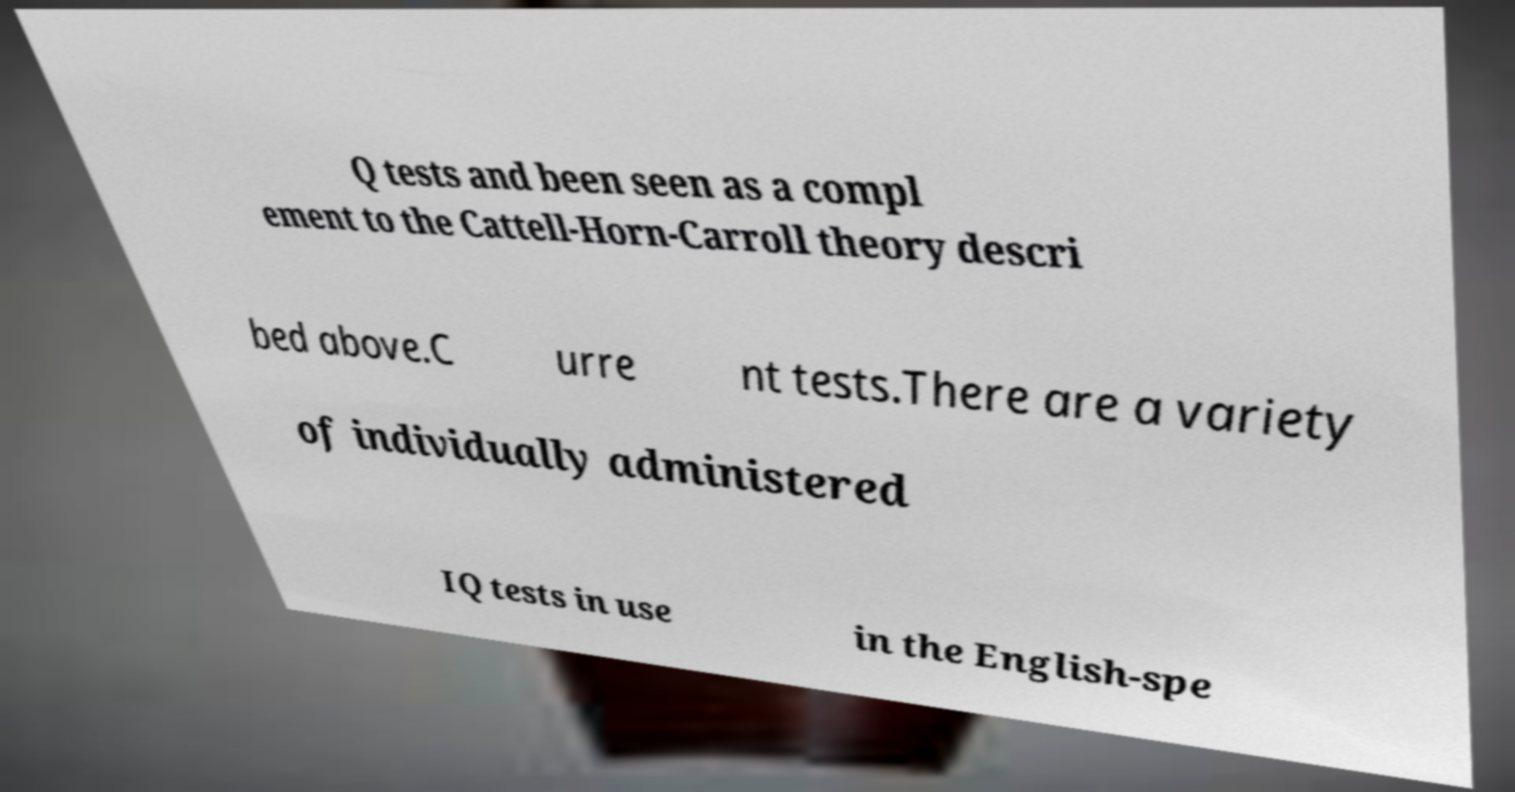I need the written content from this picture converted into text. Can you do that? Q tests and been seen as a compl ement to the Cattell-Horn-Carroll theory descri bed above.C urre nt tests.There are a variety of individually administered IQ tests in use in the English-spe 